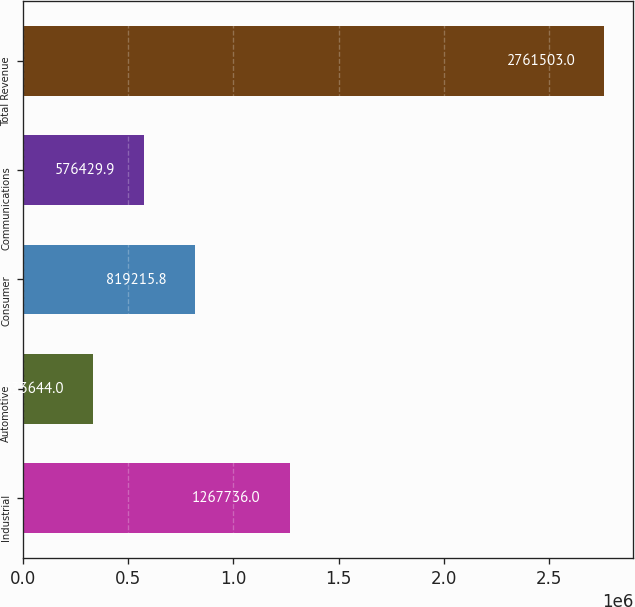Convert chart. <chart><loc_0><loc_0><loc_500><loc_500><bar_chart><fcel>Industrial<fcel>Automotive<fcel>Consumer<fcel>Communications<fcel>Total Revenue<nl><fcel>1.26774e+06<fcel>333644<fcel>819216<fcel>576430<fcel>2.7615e+06<nl></chart> 